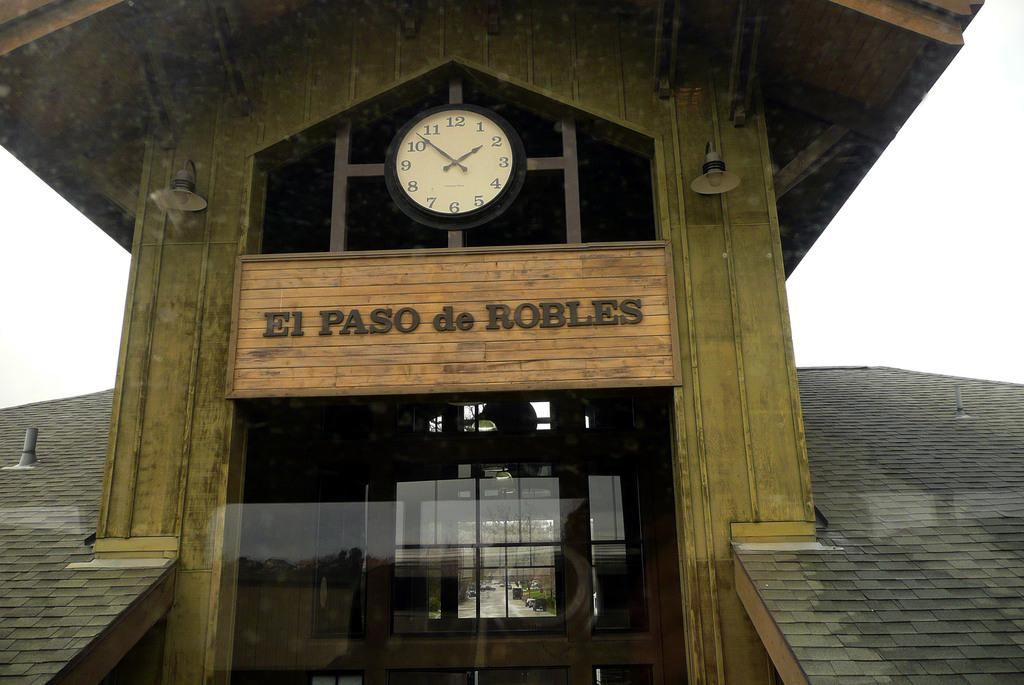<image>
Give a short and clear explanation of the subsequent image. The sign for El Paso de Robles is posted on wooden boards under a clock. 